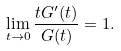<formula> <loc_0><loc_0><loc_500><loc_500>\lim _ { t \to 0 } \frac { t G ^ { \prime } ( t ) } { G ( t ) } = 1 .</formula> 